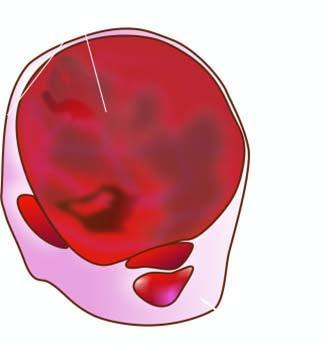does cut section show lobules of translucent gelatinous light brown parenchyma and areas of haemorrhage?
Answer the question using a single word or phrase. Yes 